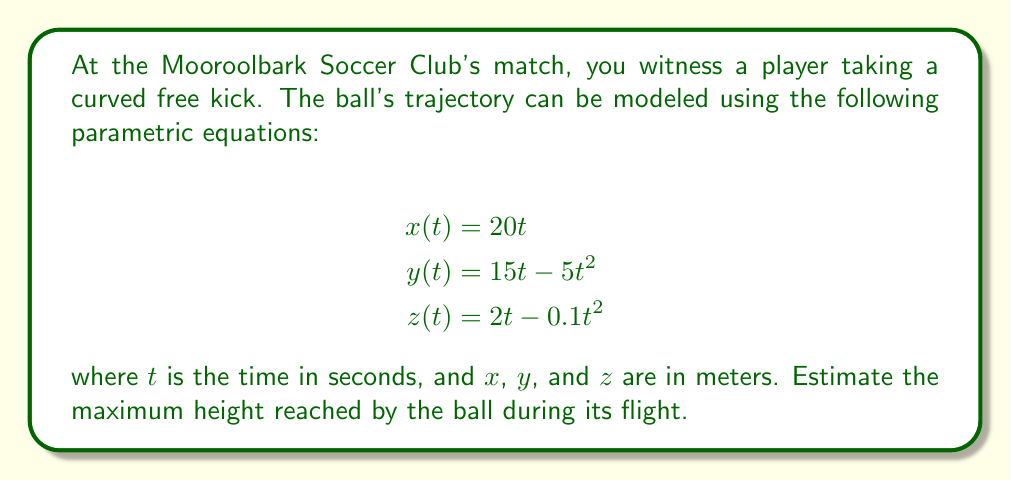Can you solve this math problem? To find the maximum height of the ball, we need to focus on the $z(t)$ equation, which represents the vertical component of the ball's trajectory.

1) The equation for $z(t)$ is:
   $$z(t) = 2t - 0.1t^2$$

2) To find the maximum height, we need to find the time $t$ when the vertical velocity is zero. The vertical velocity is the derivative of $z(t)$:
   $$\frac{dz}{dt} = 2 - 0.2t$$

3) Set this equal to zero and solve for $t$:
   $$2 - 0.2t = 0$$
   $$-0.2t = -2$$
   $$t = 10$$

4) Now that we know the time when the ball reaches its maximum height, we can plug this back into the original $z(t)$ equation:
   $$z(10) = 2(10) - 0.1(10)^2$$
   $$= 20 - 10$$
   $$= 10$$

Therefore, the maximum height reached by the ball is 10 meters.
Answer: The maximum height reached by the ball during its flight is 10 meters. 